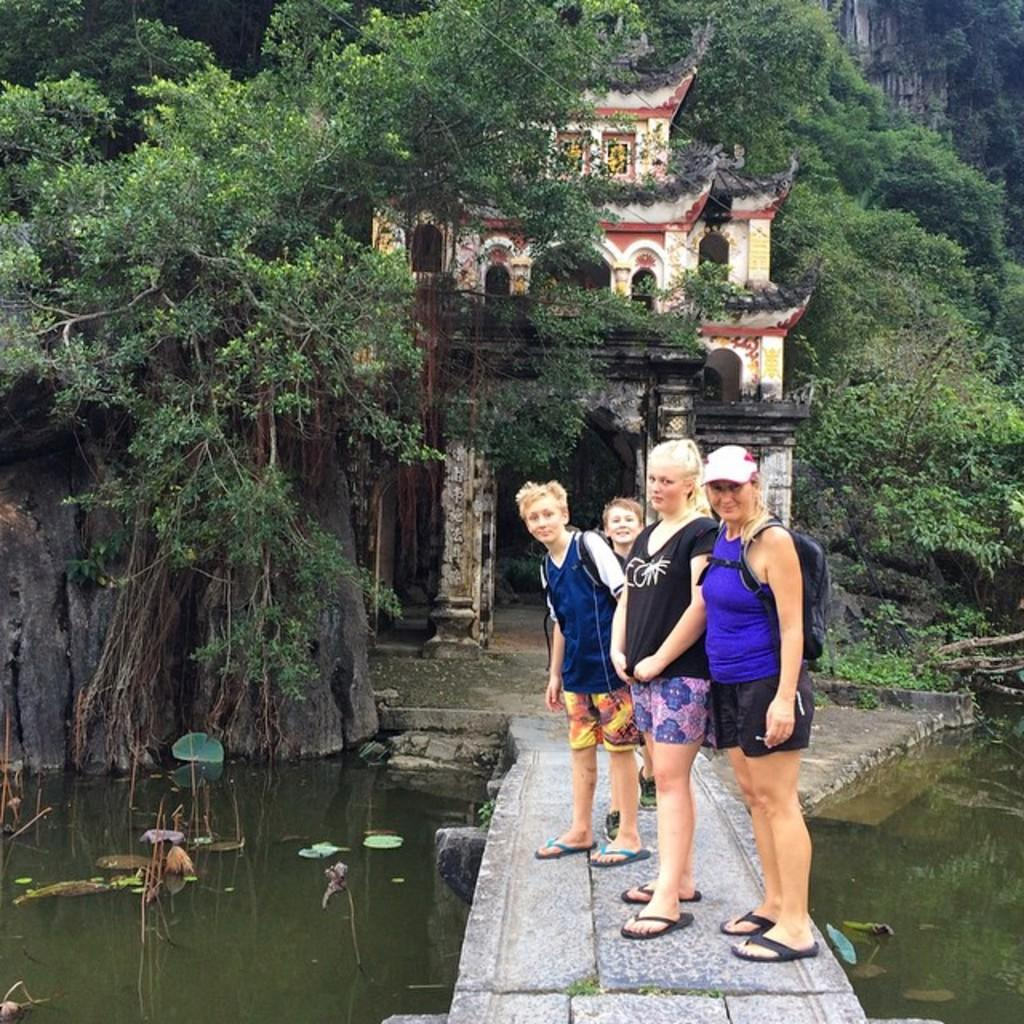What type of structure is present in the image? There is a bridge in the image. Can you describe the people in the image? There is a group of people in the image. What natural element is visible in the image? There is water visible in the image. What type of vegetation is present in the image? There are trees in the image. What man-made structures can be seen in the image? There are buildings in the image. How many trees are present in the image? There is at least one tree in the image. Can you tell me how many jellyfish are swimming in the water in the image? There are no jellyfish present in the image; it features a bridge, a group of people, water, trees, and buildings. What type of tool is being used by the person in the image? There is no person using a rake or any other tool in the image. 